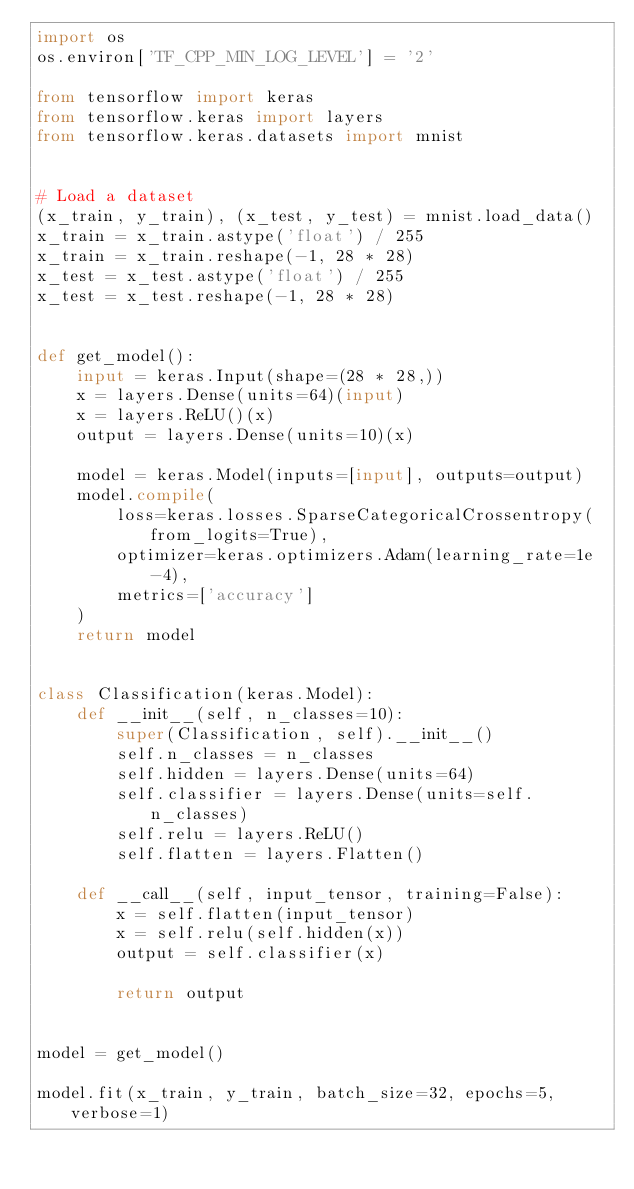<code> <loc_0><loc_0><loc_500><loc_500><_Python_>import os
os.environ['TF_CPP_MIN_LOG_LEVEL'] = '2'

from tensorflow import keras
from tensorflow.keras import layers
from tensorflow.keras.datasets import mnist


# Load a dataset
(x_train, y_train), (x_test, y_test) = mnist.load_data()
x_train = x_train.astype('float') / 255
x_train = x_train.reshape(-1, 28 * 28)
x_test = x_test.astype('float') / 255
x_test = x_test.reshape(-1, 28 * 28)


def get_model():
    input = keras.Input(shape=(28 * 28,))
    x = layers.Dense(units=64)(input)
    x = layers.ReLU()(x)
    output = layers.Dense(units=10)(x)

    model = keras.Model(inputs=[input], outputs=output)
    model.compile(
        loss=keras.losses.SparseCategoricalCrossentropy(from_logits=True),
        optimizer=keras.optimizers.Adam(learning_rate=1e-4),
        metrics=['accuracy']
    )
    return model


class Classification(keras.Model):
    def __init__(self, n_classes=10):
        super(Classification, self).__init__()
        self.n_classes = n_classes
        self.hidden = layers.Dense(units=64)
        self.classifier = layers.Dense(units=self.n_classes)
        self.relu = layers.ReLU()
        self.flatten = layers.Flatten()

    def __call__(self, input_tensor, training=False):
        x = self.flatten(input_tensor)
        x = self.relu(self.hidden(x))
        output = self.classifier(x)

        return output


model = get_model()

model.fit(x_train, y_train, batch_size=32, epochs=5, verbose=1)</code> 